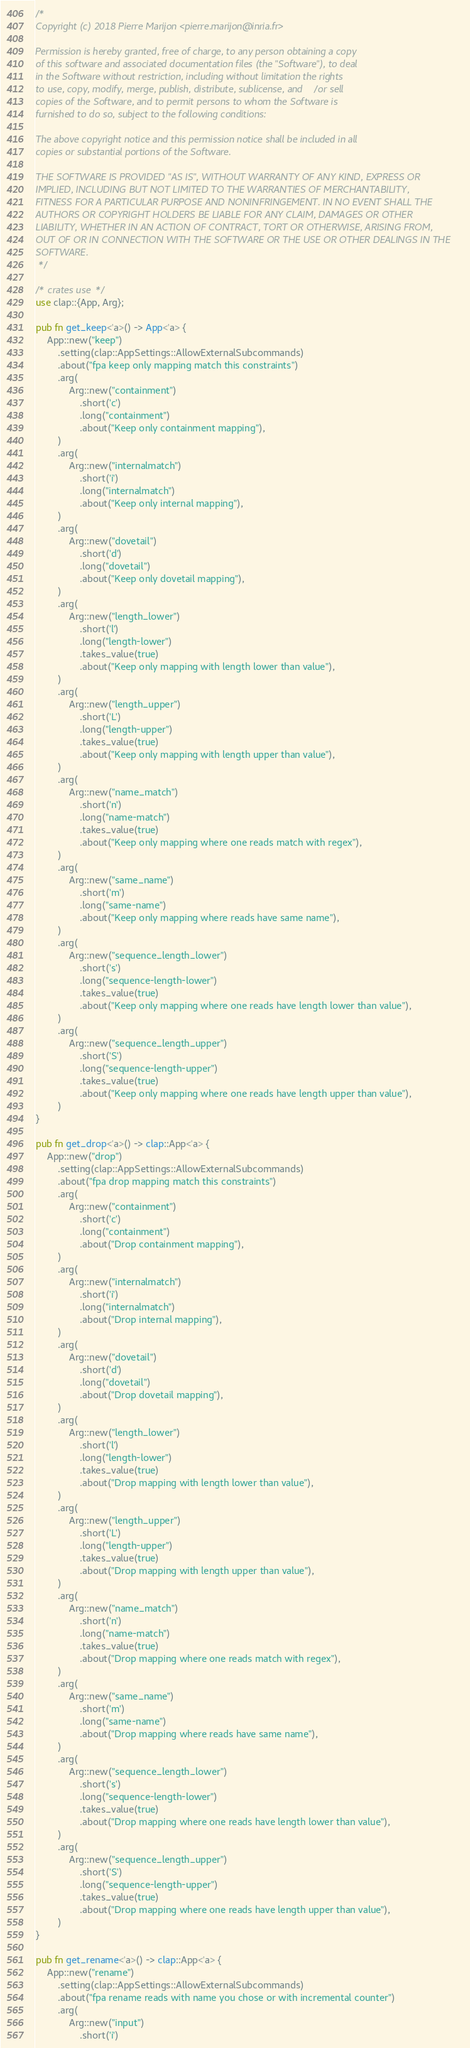<code> <loc_0><loc_0><loc_500><loc_500><_Rust_>/*
Copyright (c) 2018 Pierre Marijon <pierre.marijon@inria.fr>

Permission is hereby granted, free of charge, to any person obtaining a copy
of this software and associated documentation files (the "Software"), to deal
in the Software without restriction, including without limitation the rights
to use, copy, modify, merge, publish, distribute, sublicense, and/or sell
copies of the Software, and to permit persons to whom the Software is
furnished to do so, subject to the following conditions:

The above copyright notice and this permission notice shall be included in all
copies or substantial portions of the Software.

THE SOFTWARE IS PROVIDED "AS IS", WITHOUT WARRANTY OF ANY KIND, EXPRESS OR
IMPLIED, INCLUDING BUT NOT LIMITED TO THE WARRANTIES OF MERCHANTABILITY,
FITNESS FOR A PARTICULAR PURPOSE AND NONINFRINGEMENT. IN NO EVENT SHALL THE
AUTHORS OR COPYRIGHT HOLDERS BE LIABLE FOR ANY CLAIM, DAMAGES OR OTHER
LIABILITY, WHETHER IN AN ACTION OF CONTRACT, TORT OR OTHERWISE, ARISING FROM,
OUT OF OR IN CONNECTION WITH THE SOFTWARE OR THE USE OR OTHER DEALINGS IN THE
SOFTWARE.
 */

/* crates use */
use clap::{App, Arg};

pub fn get_keep<'a>() -> App<'a> {
    App::new("keep")
        .setting(clap::AppSettings::AllowExternalSubcommands)
        .about("fpa keep only mapping match this constraints")
        .arg(
            Arg::new("containment")
                .short('c')
                .long("containment")
                .about("Keep only containment mapping"),
        )
        .arg(
            Arg::new("internalmatch")
                .short('i')
                .long("internalmatch")
                .about("Keep only internal mapping"),
        )
        .arg(
            Arg::new("dovetail")
                .short('d')
                .long("dovetail")
                .about("Keep only dovetail mapping"),
        )
        .arg(
            Arg::new("length_lower")
                .short('l')
                .long("length-lower")
                .takes_value(true)
                .about("Keep only mapping with length lower than value"),
        )
        .arg(
            Arg::new("length_upper")
                .short('L')
                .long("length-upper")
                .takes_value(true)
                .about("Keep only mapping with length upper than value"),
        )
        .arg(
            Arg::new("name_match")
                .short('n')
                .long("name-match")
                .takes_value(true)
                .about("Keep only mapping where one reads match with regex"),
        )
        .arg(
            Arg::new("same_name")
                .short('m')
                .long("same-name")
                .about("Keep only mapping where reads have same name"),
        )
        .arg(
            Arg::new("sequence_length_lower")
                .short('s')
                .long("sequence-length-lower")
                .takes_value(true)
                .about("Keep only mapping where one reads have length lower than value"),
        )
        .arg(
            Arg::new("sequence_length_upper")
                .short('S')
                .long("sequence-length-upper")
                .takes_value(true)
                .about("Keep only mapping where one reads have length upper than value"),
        )
}

pub fn get_drop<'a>() -> clap::App<'a> {
    App::new("drop")
        .setting(clap::AppSettings::AllowExternalSubcommands)
        .about("fpa drop mapping match this constraints")
        .arg(
            Arg::new("containment")
                .short('c')
                .long("containment")
                .about("Drop containment mapping"),
        )
        .arg(
            Arg::new("internalmatch")
                .short('i')
                .long("internalmatch")
                .about("Drop internal mapping"),
        )
        .arg(
            Arg::new("dovetail")
                .short('d')
                .long("dovetail")
                .about("Drop dovetail mapping"),
        )
        .arg(
            Arg::new("length_lower")
                .short('l')
                .long("length-lower")
                .takes_value(true)
                .about("Drop mapping with length lower than value"),
        )
        .arg(
            Arg::new("length_upper")
                .short('L')
                .long("length-upper")
                .takes_value(true)
                .about("Drop mapping with length upper than value"),
        )
        .arg(
            Arg::new("name_match")
                .short('n')
                .long("name-match")
                .takes_value(true)
                .about("Drop mapping where one reads match with regex"),
        )
        .arg(
            Arg::new("same_name")
                .short('m')
                .long("same-name")
                .about("Drop mapping where reads have same name"),
        )
        .arg(
            Arg::new("sequence_length_lower")
                .short('s')
                .long("sequence-length-lower")
                .takes_value(true)
                .about("Drop mapping where one reads have length lower than value"),
        )
        .arg(
            Arg::new("sequence_length_upper")
                .short('S')
                .long("sequence-length-upper")
                .takes_value(true)
                .about("Drop mapping where one reads have length upper than value"),
        )
}

pub fn get_rename<'a>() -> clap::App<'a> {
    App::new("rename")
        .setting(clap::AppSettings::AllowExternalSubcommands)
        .about("fpa rename reads with name you chose or with incremental counter")
        .arg(
            Arg::new("input")
                .short('i')</code> 